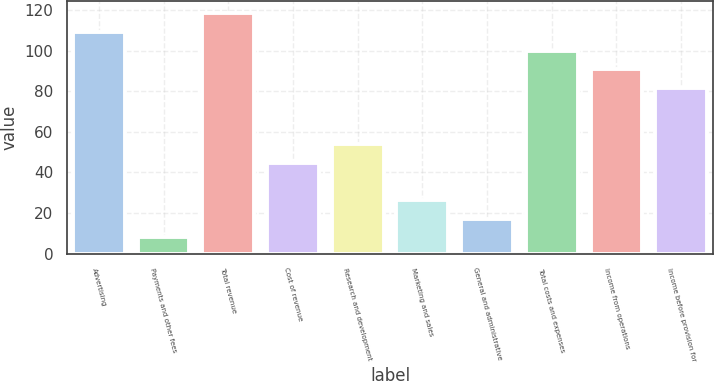Convert chart. <chart><loc_0><loc_0><loc_500><loc_500><bar_chart><fcel>Advertising<fcel>Payments and other fees<fcel>Total revenue<fcel>Cost of revenue<fcel>Research and development<fcel>Marketing and sales<fcel>General and administrative<fcel>Total costs and expenses<fcel>Income from operations<fcel>Income before provision for<nl><fcel>109.2<fcel>8<fcel>118.4<fcel>44.8<fcel>54<fcel>26.4<fcel>17.2<fcel>100<fcel>90.8<fcel>81.6<nl></chart> 